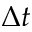Convert formula to latex. <formula><loc_0><loc_0><loc_500><loc_500>\Delta t</formula> 